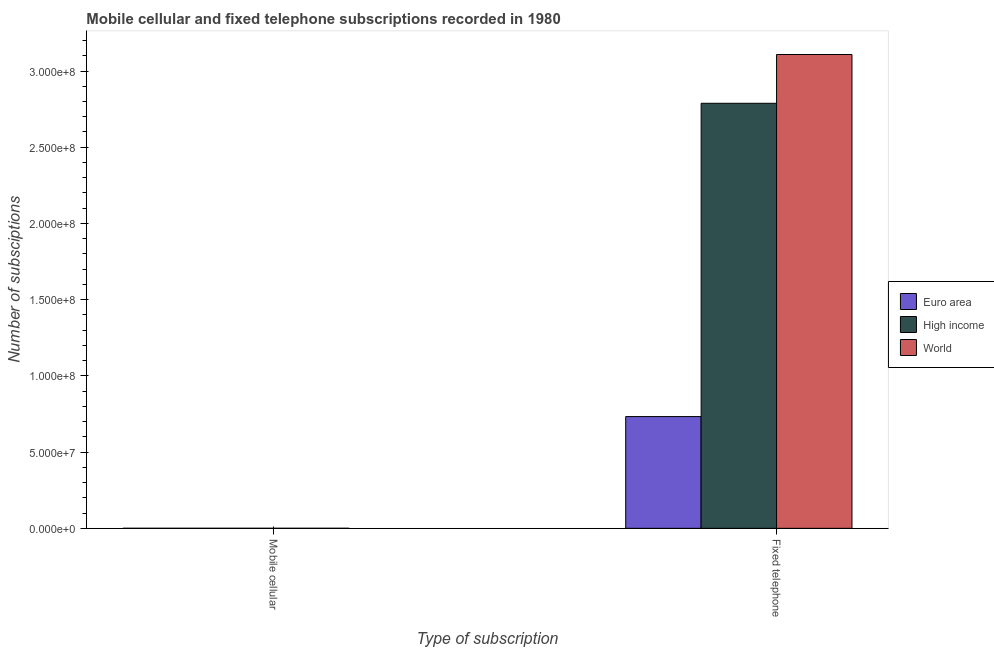How many groups of bars are there?
Offer a terse response. 2. Are the number of bars on each tick of the X-axis equal?
Make the answer very short. Yes. How many bars are there on the 1st tick from the left?
Your answer should be compact. 3. How many bars are there on the 2nd tick from the right?
Your response must be concise. 3. What is the label of the 1st group of bars from the left?
Offer a terse response. Mobile cellular. What is the number of mobile cellular subscriptions in Euro area?
Your answer should be very brief. 2.35e+04. Across all countries, what is the maximum number of mobile cellular subscriptions?
Provide a succinct answer. 2.35e+04. Across all countries, what is the minimum number of mobile cellular subscriptions?
Provide a short and direct response. 2.35e+04. In which country was the number of mobile cellular subscriptions minimum?
Keep it short and to the point. Euro area. What is the total number of fixed telephone subscriptions in the graph?
Provide a short and direct response. 6.63e+08. What is the difference between the number of fixed telephone subscriptions in High income and the number of mobile cellular subscriptions in Euro area?
Your answer should be compact. 2.79e+08. What is the average number of fixed telephone subscriptions per country?
Keep it short and to the point. 2.21e+08. What is the difference between the number of mobile cellular subscriptions and number of fixed telephone subscriptions in High income?
Your response must be concise. -2.79e+08. What is the ratio of the number of fixed telephone subscriptions in Euro area to that in World?
Your response must be concise. 0.24. In how many countries, is the number of fixed telephone subscriptions greater than the average number of fixed telephone subscriptions taken over all countries?
Ensure brevity in your answer.  2. Are all the bars in the graph horizontal?
Give a very brief answer. No. How many countries are there in the graph?
Keep it short and to the point. 3. What is the difference between two consecutive major ticks on the Y-axis?
Provide a short and direct response. 5.00e+07. Does the graph contain any zero values?
Offer a very short reply. No. Does the graph contain grids?
Your response must be concise. No. Where does the legend appear in the graph?
Your answer should be very brief. Center right. How many legend labels are there?
Keep it short and to the point. 3. How are the legend labels stacked?
Your answer should be very brief. Vertical. What is the title of the graph?
Offer a terse response. Mobile cellular and fixed telephone subscriptions recorded in 1980. What is the label or title of the X-axis?
Your response must be concise. Type of subscription. What is the label or title of the Y-axis?
Give a very brief answer. Number of subsciptions. What is the Number of subsciptions of Euro area in Mobile cellular?
Provide a short and direct response. 2.35e+04. What is the Number of subsciptions in High income in Mobile cellular?
Your answer should be very brief. 2.35e+04. What is the Number of subsciptions in World in Mobile cellular?
Offer a very short reply. 2.35e+04. What is the Number of subsciptions in Euro area in Fixed telephone?
Offer a terse response. 7.33e+07. What is the Number of subsciptions of High income in Fixed telephone?
Your answer should be very brief. 2.79e+08. What is the Number of subsciptions of World in Fixed telephone?
Provide a succinct answer. 3.11e+08. Across all Type of subscription, what is the maximum Number of subsciptions in Euro area?
Give a very brief answer. 7.33e+07. Across all Type of subscription, what is the maximum Number of subsciptions of High income?
Offer a terse response. 2.79e+08. Across all Type of subscription, what is the maximum Number of subsciptions in World?
Your response must be concise. 3.11e+08. Across all Type of subscription, what is the minimum Number of subsciptions of Euro area?
Your answer should be compact. 2.35e+04. Across all Type of subscription, what is the minimum Number of subsciptions of High income?
Offer a terse response. 2.35e+04. Across all Type of subscription, what is the minimum Number of subsciptions of World?
Your answer should be compact. 2.35e+04. What is the total Number of subsciptions in Euro area in the graph?
Offer a very short reply. 7.33e+07. What is the total Number of subsciptions in High income in the graph?
Make the answer very short. 2.79e+08. What is the total Number of subsciptions of World in the graph?
Give a very brief answer. 3.11e+08. What is the difference between the Number of subsciptions of Euro area in Mobile cellular and that in Fixed telephone?
Keep it short and to the point. -7.33e+07. What is the difference between the Number of subsciptions of High income in Mobile cellular and that in Fixed telephone?
Provide a succinct answer. -2.79e+08. What is the difference between the Number of subsciptions in World in Mobile cellular and that in Fixed telephone?
Ensure brevity in your answer.  -3.11e+08. What is the difference between the Number of subsciptions in Euro area in Mobile cellular and the Number of subsciptions in High income in Fixed telephone?
Provide a succinct answer. -2.79e+08. What is the difference between the Number of subsciptions in Euro area in Mobile cellular and the Number of subsciptions in World in Fixed telephone?
Make the answer very short. -3.11e+08. What is the difference between the Number of subsciptions of High income in Mobile cellular and the Number of subsciptions of World in Fixed telephone?
Offer a terse response. -3.11e+08. What is the average Number of subsciptions of Euro area per Type of subscription?
Provide a short and direct response. 3.67e+07. What is the average Number of subsciptions in High income per Type of subscription?
Make the answer very short. 1.39e+08. What is the average Number of subsciptions of World per Type of subscription?
Provide a succinct answer. 1.55e+08. What is the difference between the Number of subsciptions in Euro area and Number of subsciptions in High income in Mobile cellular?
Provide a succinct answer. 0. What is the difference between the Number of subsciptions in Euro area and Number of subsciptions in World in Mobile cellular?
Ensure brevity in your answer.  0. What is the difference between the Number of subsciptions in Euro area and Number of subsciptions in High income in Fixed telephone?
Provide a short and direct response. -2.06e+08. What is the difference between the Number of subsciptions of Euro area and Number of subsciptions of World in Fixed telephone?
Provide a succinct answer. -2.38e+08. What is the difference between the Number of subsciptions in High income and Number of subsciptions in World in Fixed telephone?
Ensure brevity in your answer.  -3.20e+07. What is the ratio of the Number of subsciptions in World in Mobile cellular to that in Fixed telephone?
Your answer should be very brief. 0. What is the difference between the highest and the second highest Number of subsciptions of Euro area?
Ensure brevity in your answer.  7.33e+07. What is the difference between the highest and the second highest Number of subsciptions of High income?
Give a very brief answer. 2.79e+08. What is the difference between the highest and the second highest Number of subsciptions of World?
Provide a succinct answer. 3.11e+08. What is the difference between the highest and the lowest Number of subsciptions of Euro area?
Offer a terse response. 7.33e+07. What is the difference between the highest and the lowest Number of subsciptions in High income?
Your answer should be compact. 2.79e+08. What is the difference between the highest and the lowest Number of subsciptions of World?
Ensure brevity in your answer.  3.11e+08. 